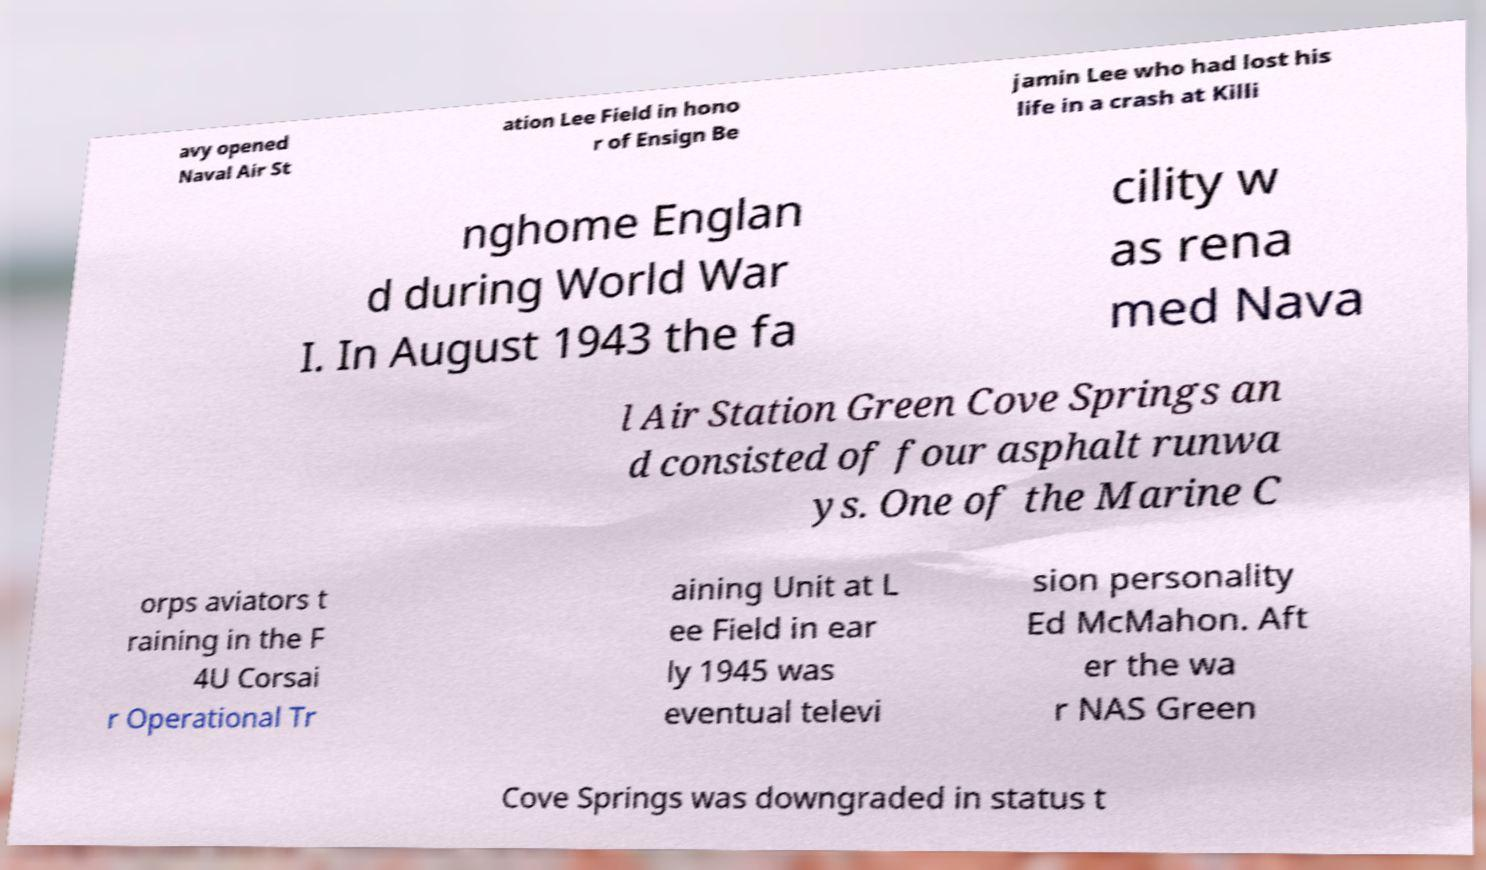For documentation purposes, I need the text within this image transcribed. Could you provide that? avy opened Naval Air St ation Lee Field in hono r of Ensign Be jamin Lee who had lost his life in a crash at Killi nghome Englan d during World War I. In August 1943 the fa cility w as rena med Nava l Air Station Green Cove Springs an d consisted of four asphalt runwa ys. One of the Marine C orps aviators t raining in the F 4U Corsai r Operational Tr aining Unit at L ee Field in ear ly 1945 was eventual televi sion personality Ed McMahon. Aft er the wa r NAS Green Cove Springs was downgraded in status t 